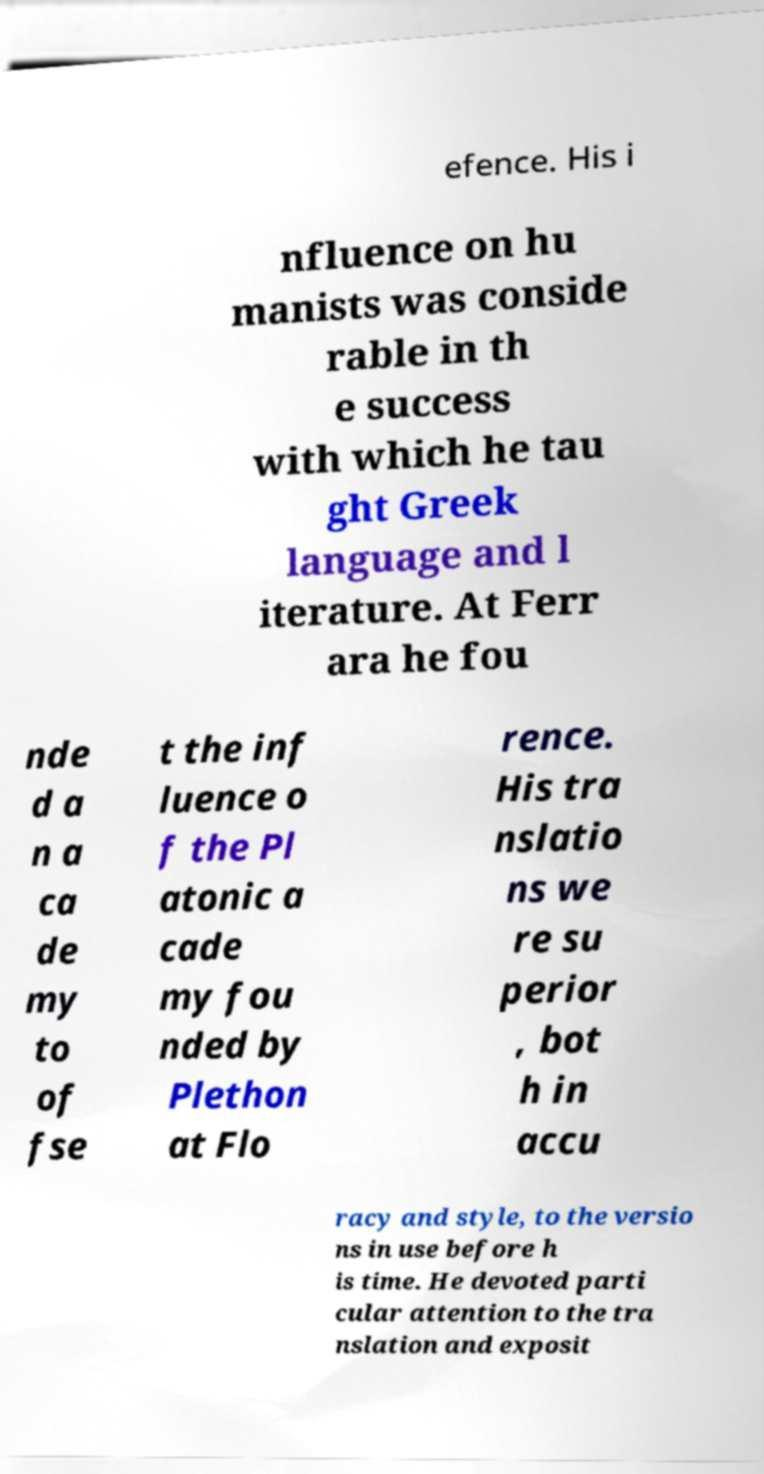Can you read and provide the text displayed in the image?This photo seems to have some interesting text. Can you extract and type it out for me? efence. His i nfluence on hu manists was conside rable in th e success with which he tau ght Greek language and l iterature. At Ferr ara he fou nde d a n a ca de my to of fse t the inf luence o f the Pl atonic a cade my fou nded by Plethon at Flo rence. His tra nslatio ns we re su perior , bot h in accu racy and style, to the versio ns in use before h is time. He devoted parti cular attention to the tra nslation and exposit 